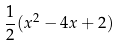Convert formula to latex. <formula><loc_0><loc_0><loc_500><loc_500>\frac { 1 } { 2 } ( x ^ { 2 } - 4 x + 2 )</formula> 